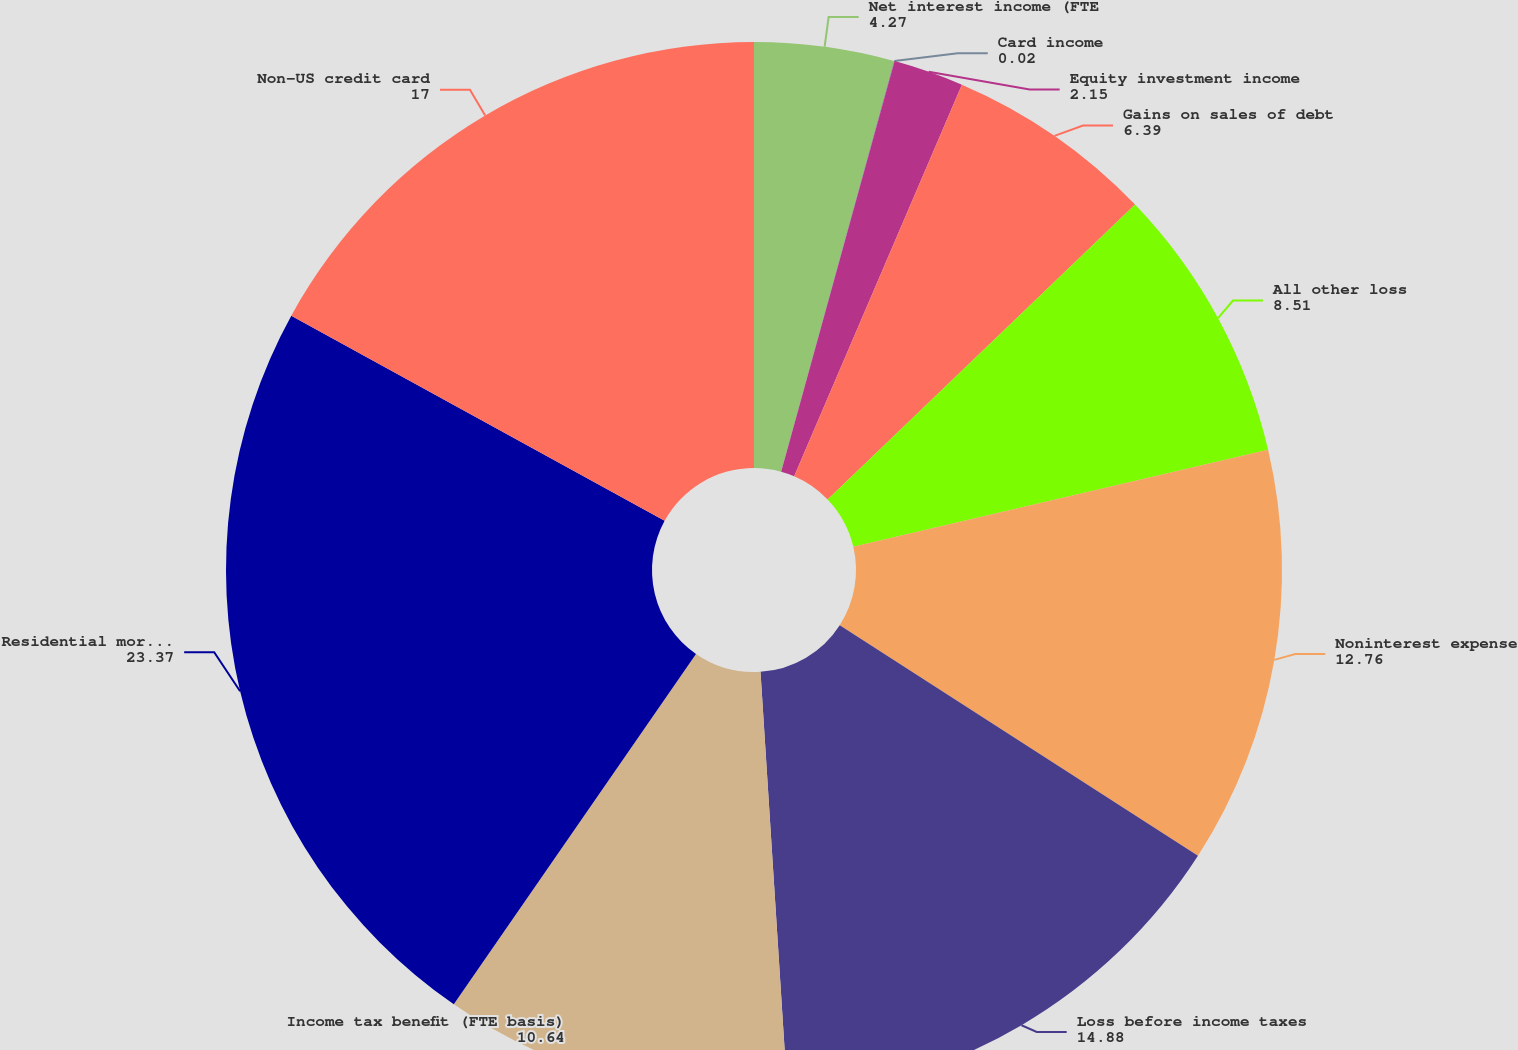<chart> <loc_0><loc_0><loc_500><loc_500><pie_chart><fcel>Net interest income (FTE<fcel>Card income<fcel>Equity investment income<fcel>Gains on sales of debt<fcel>All other loss<fcel>Noninterest expense<fcel>Loss before income taxes<fcel>Income tax benefit (FTE basis)<fcel>Residential mortgage<fcel>Non-US credit card<nl><fcel>4.27%<fcel>0.02%<fcel>2.15%<fcel>6.39%<fcel>8.51%<fcel>12.76%<fcel>14.88%<fcel>10.64%<fcel>23.37%<fcel>17.0%<nl></chart> 